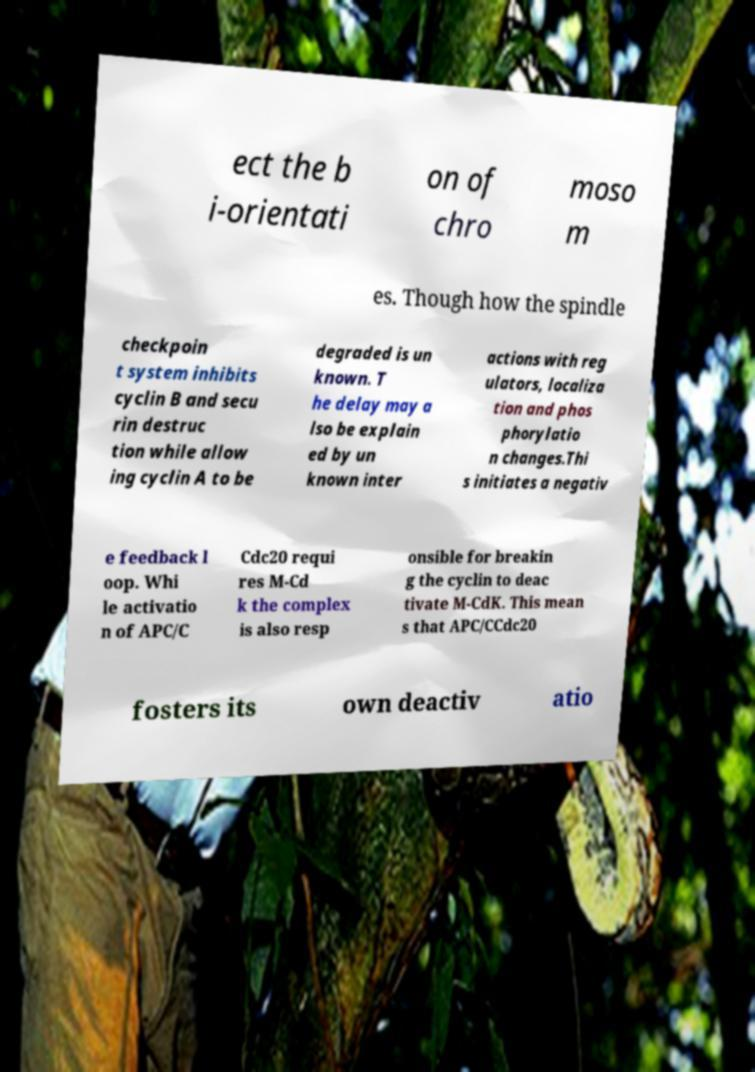Please identify and transcribe the text found in this image. ect the b i-orientati on of chro moso m es. Though how the spindle checkpoin t system inhibits cyclin B and secu rin destruc tion while allow ing cyclin A to be degraded is un known. T he delay may a lso be explain ed by un known inter actions with reg ulators, localiza tion and phos phorylatio n changes.Thi s initiates a negativ e feedback l oop. Whi le activatio n of APC/C Cdc20 requi res M-Cd k the complex is also resp onsible for breakin g the cyclin to deac tivate M-CdK. This mean s that APC/CCdc20 fosters its own deactiv atio 